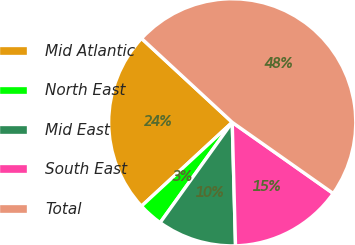<chart> <loc_0><loc_0><loc_500><loc_500><pie_chart><fcel>Mid Atlantic<fcel>North East<fcel>Mid East<fcel>South East<fcel>Total<nl><fcel>23.75%<fcel>3.22%<fcel>10.34%<fcel>14.81%<fcel>47.89%<nl></chart> 